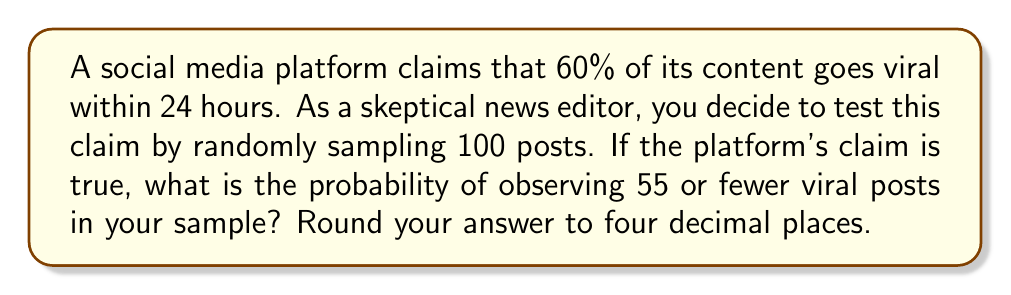Help me with this question. To solve this problem, we'll use the binomial distribution and its normal approximation:

1) Let X be the number of viral posts in our sample. If the platform's claim is true, X follows a binomial distribution with n = 100 and p = 0.6.

2) We want to find P(X ≤ 55). Since n is large (> 30) and np and n(1-p) are both > 5, we can use the normal approximation to the binomial distribution.

3) The mean of this distribution is:
   $$μ = np = 100 * 0.6 = 60$$

4) The standard deviation is:
   $$σ = \sqrt{np(1-p)} = \sqrt{100 * 0.6 * 0.4} = \sqrt{24} = 4.899$$

5) We need to apply a continuity correction. Instead of P(X ≤ 55), we calculate P(X < 55.5).

6) Convert to a z-score:
   $$z = \frac{55.5 - μ}{σ} = \frac{55.5 - 60}{4.899} = -0.918$$

7) Use a standard normal table or calculator to find the probability:
   P(Z < -0.918) ≈ 0.1793

Therefore, the probability of observing 55 or fewer viral posts in the sample is approximately 0.1793 or 17.93%.
Answer: 0.1793 